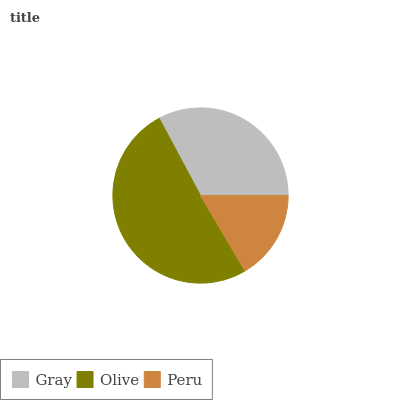Is Peru the minimum?
Answer yes or no. Yes. Is Olive the maximum?
Answer yes or no. Yes. Is Olive the minimum?
Answer yes or no. No. Is Peru the maximum?
Answer yes or no. No. Is Olive greater than Peru?
Answer yes or no. Yes. Is Peru less than Olive?
Answer yes or no. Yes. Is Peru greater than Olive?
Answer yes or no. No. Is Olive less than Peru?
Answer yes or no. No. Is Gray the high median?
Answer yes or no. Yes. Is Gray the low median?
Answer yes or no. Yes. Is Peru the high median?
Answer yes or no. No. Is Peru the low median?
Answer yes or no. No. 